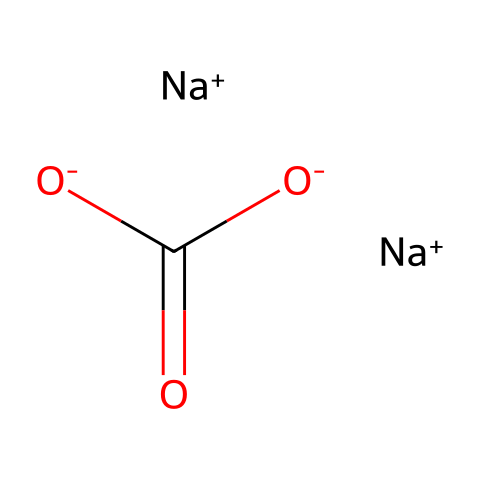What is the molecular formula of this chemical? The SMILES representation shows two sodium ions (Na+), one carbonate group (C(=O)[O-]C(=O)[O-]), hence the molecular formula is Na2CO3.
Answer: Na2CO3 How many sodium atoms are present in this structure? The SMILES representation includes two occurrences of [Na+], indicating there are two sodium atoms in the chemical.
Answer: 2 What type of chemical compound is sodium carbonate classified as? Sodium carbonate is an inorganic salt, derived from the combination of sodium ions and carbonate ions.
Answer: inorganic salt How many oxygen atoms are found in sodium carbonate? The structure contains three oxygen atoms in the carbonate group (O- and two O=), therefore there are three oxygen atoms in total.
Answer: 3 Which part of the molecule contributes to its alkalinity? The carbonate ion (CO3) part contains oxygen anions, which make the substance alkaline in solution.
Answer: carbonate ion What role does sodium carbonate play in cleaning products? Sodium carbonate acts as a water softener and a cleaning agent, helping to remove stains and enhance the effectiveness of other detergents.
Answer: cleaning agent 